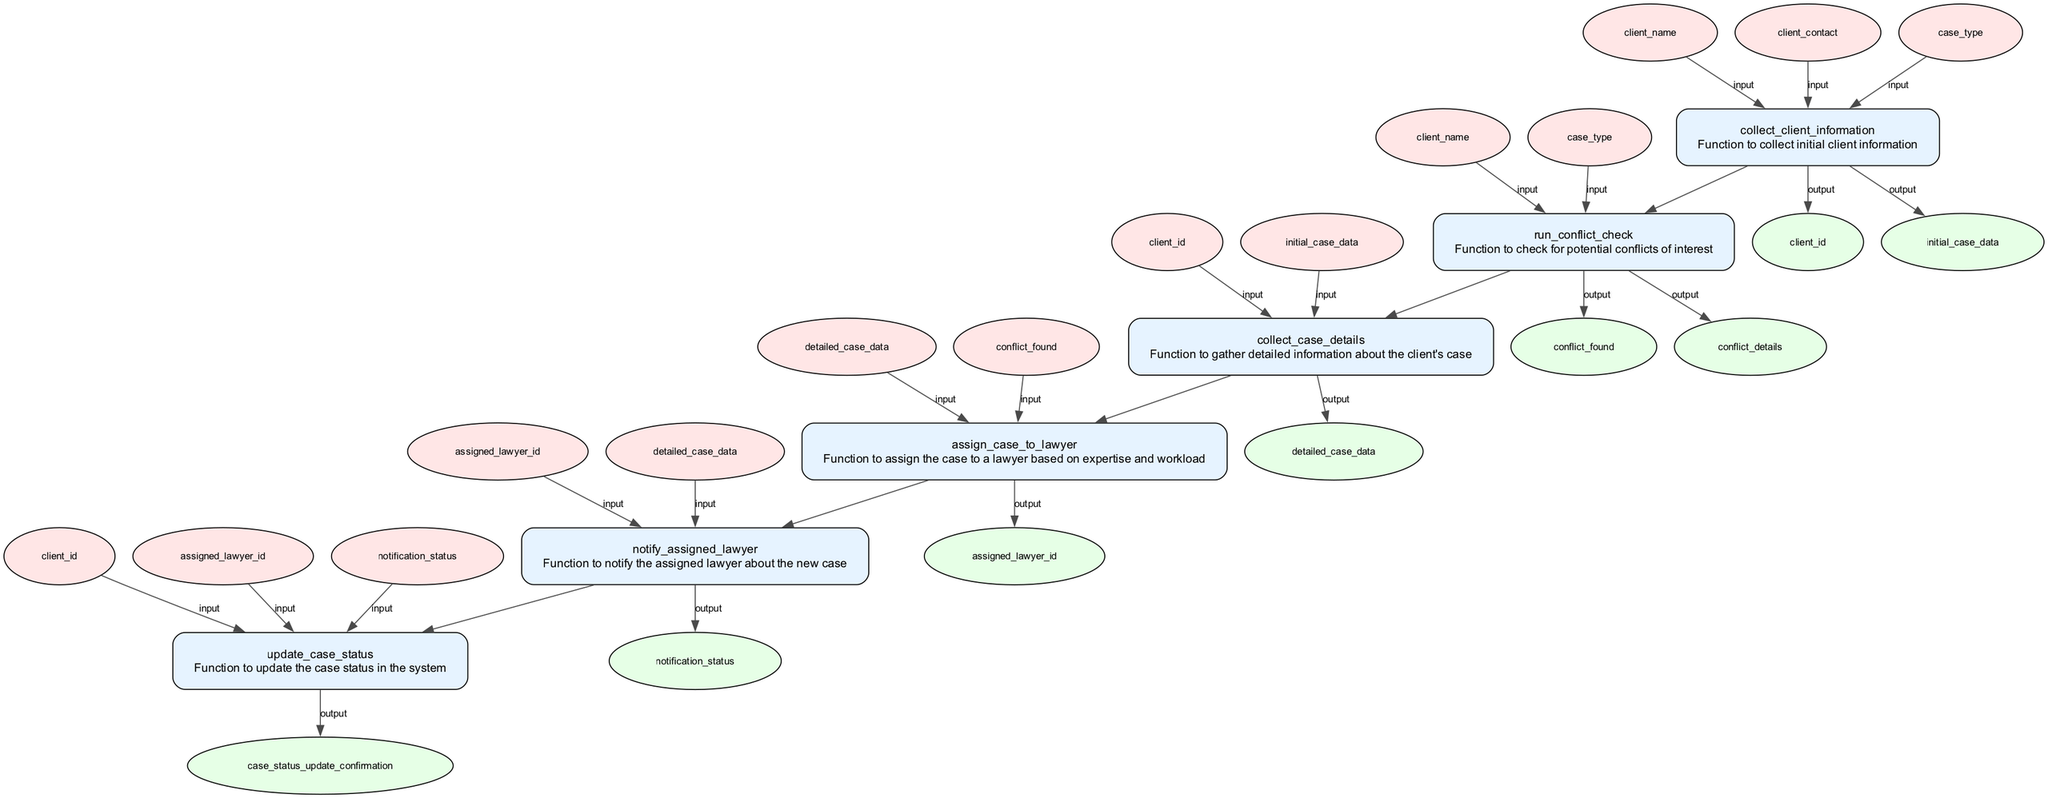what is the first function in the process? The first function in the process is "collect_client_information," which is indicated as the starting point in the flowchart.
Answer: collect_client_information how many output nodes are associated with the function 'assign_case_to_lawyer'? The function 'assign_case_to_lawyer' has one output node, which indicates that it gives one result after processing.
Answer: one what outputs does 'collect_client_information' produce? The function 'collect_client_information' produces two outputs as shown in the diagram, which are 'client_id' and 'initial_case_data.'
Answer: client_id, initial_case_data what is the relationship between 'run_conflict_check' and 'collect_case_details'? The relationship between 'run_conflict_check' and 'collect_case_details' is sequential; the output of 'run_conflict_check' is an input for 'collect_case_details,' indicating a flow from one function to the next.
Answer: sequential how many total functions are in this process? The flowchart lists a total of six functions that are part of the client intake and case assignment process, covering all steps from initial information collection to case status update.
Answer: six what is the final function in the sequence? The final function in the sequence of the process is 'update_case_status,' which indicates the last step in finalizing the case handling.
Answer: update_case_status which function checks for potential conflicts of interest? The function that checks for potential conflicts of interest is 'run_conflict_check,' as indicated by its name and description in the diagram.
Answer: run_conflict_check how does 'notify_assigned_lawyer' relate to 'assign_case_to_lawyer'? 'notify_assigned_lawyer' directly follows 'assign_case_to_lawyer' in the process, indicating it is the next step after the case has been assigned to a lawyer.
Answer: next step 